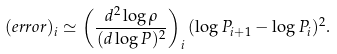Convert formula to latex. <formula><loc_0><loc_0><loc_500><loc_500>( e r r o r ) _ { i } \simeq \left ( \frac { d ^ { 2 } \log \rho } { ( d \log P ) ^ { 2 } } \right ) _ { i } ( \log P _ { i + 1 } - \log P _ { i } ) ^ { 2 } .</formula> 